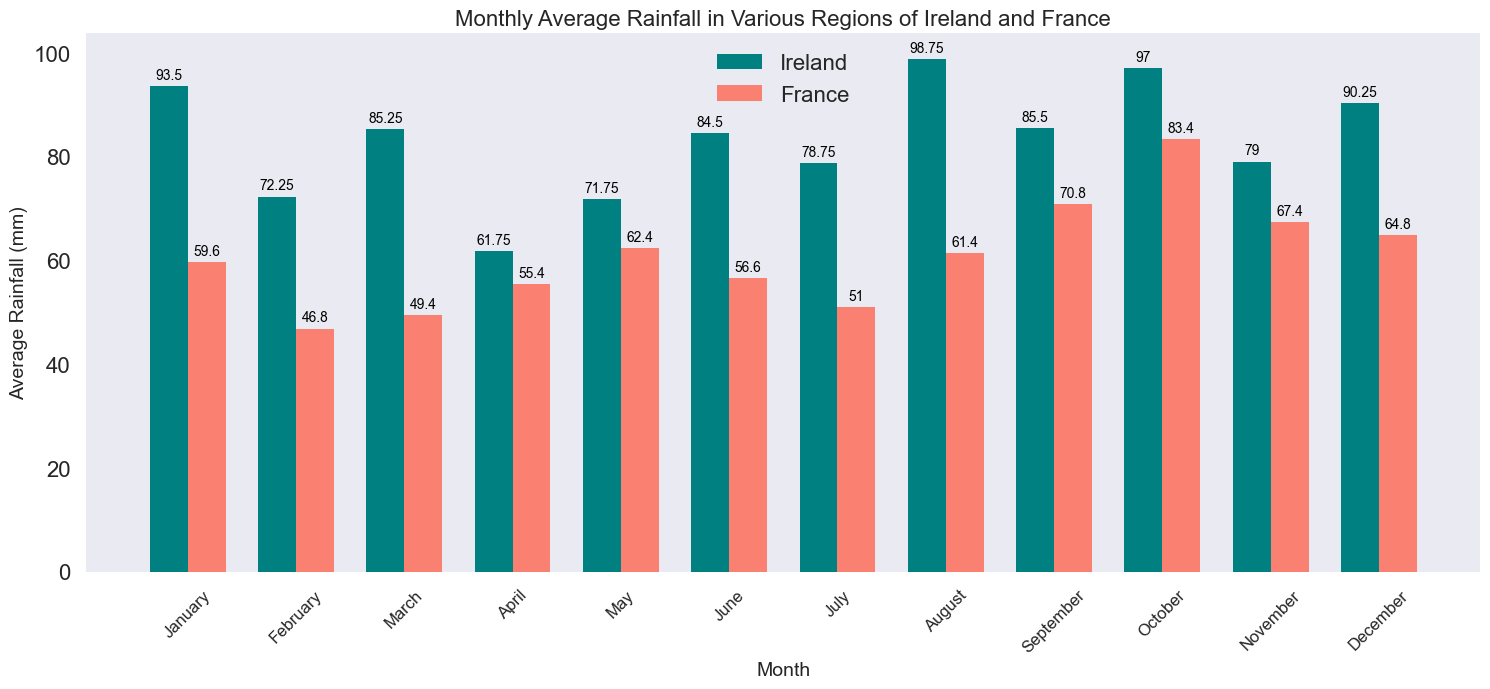What is the average rainfall in May for Ireland and France? In the plot, each bar represents the average rainfall for a month. To find the average rainfall in May, look for the bar labeled "May" and compare the heights of the two bars: one for Ireland and one for France. The heights indicate the average rainfall in millimeters for that month.
Answer: Ireland: ~81 mm, France: ~74 mm Which country has more rainfall in August? For August, locate the bars in the plot for that month. Compare the height of the bar for Ireland with the bar for France. The taller bar indicates the country with more rainfall.
Answer: Ireland How does the average rainfall in January compare between Ireland and France? Look at the height of the bars for January for both Ireland and France. Compare their heights to determine which has more or less rainfall.
Answer: Ireland has more rainfall Find the difference in average rainfall between June and December for France. Identify the bars for June and December for France. Note down their rainfall values and subtract the June value from the December value to get the difference.
Answer: ~30 mm Which region, between Ireland and France, experiences the highest monthly average rainfall and in which month? Look for the tallest bar across all months for both Ireland and France. The highest bar indicates the peak monthly average rainfall and the corresponding month.
Answer: Ireland in August What is the combined average rainfall in July for both countries? Identify the bars for July for both Ireland and France. Sum the heights of these bars to get the combined average rainfall.
Answer: ~114 mm Compare the rainfall in October between Ireland and France and identify which has less rainfall. Find the bars for October for both countries. The shorter bar indicates less rainfall.
Answer: France What is the average rainfall in April for Ireland and November for France? Look at the respective bars for Ireland in April and France in November. Their heights give the average rainfall for these months.
Answer: Ireland in April: ~60 mm, France in November: ~67 mm Which month has the least rainfall in France? Identify the lowest bar in the France series across all months. The month corresponding to this bar is the one with the least rainfall.
Answer: July Calculate the difference in average rainfall between March and November for Ireland. Look at the bars for March and November for Ireland, subtract the March value from the November value to find the difference.
Answer: -10 mm 